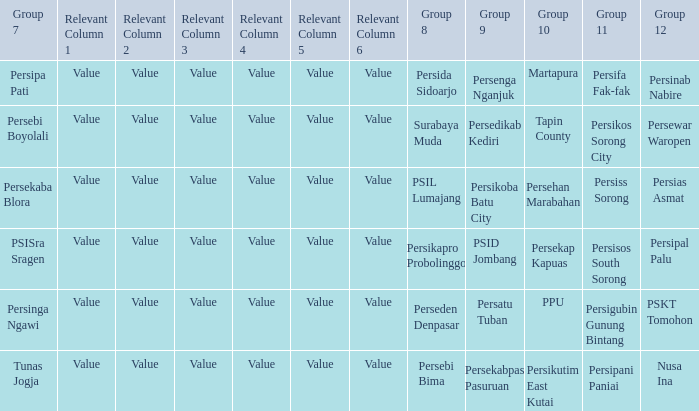Who played in group 12 when Group 9 played psid jombang? Persipal Palu. 